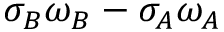Convert formula to latex. <formula><loc_0><loc_0><loc_500><loc_500>\sigma _ { B } \omega _ { B } - \sigma _ { A } \omega _ { A }</formula> 